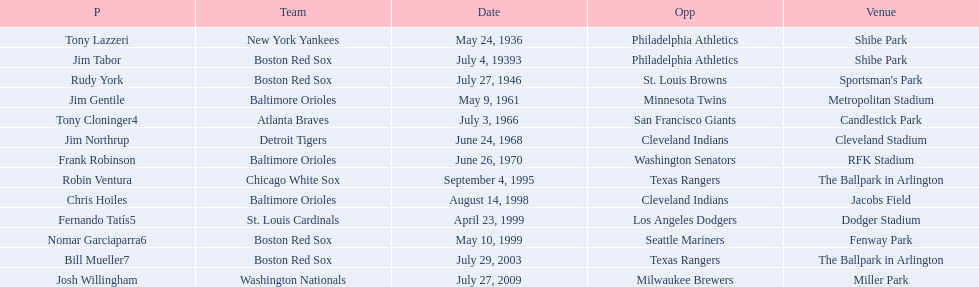What is the name of the player for the new york yankees in 1936? Tony Lazzeri. 